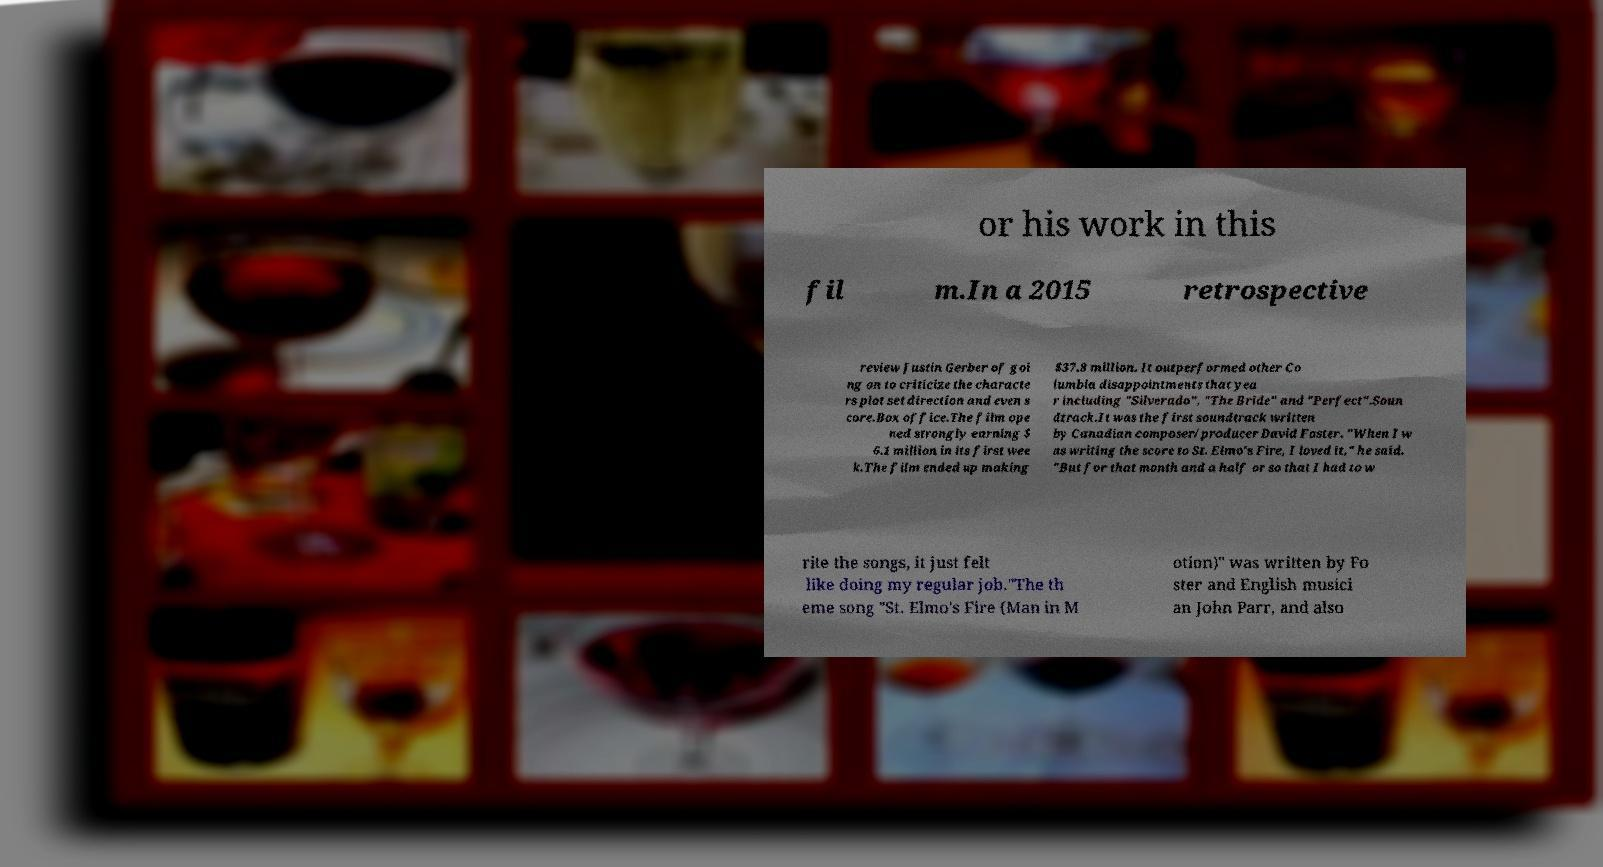Could you extract and type out the text from this image? or his work in this fil m.In a 2015 retrospective review Justin Gerber of goi ng on to criticize the characte rs plot set direction and even s core.Box office.The film ope ned strongly earning $ 6.1 million in its first wee k.The film ended up making $37.8 million. It outperformed other Co lumbia disappointments that yea r including "Silverado", "The Bride" and "Perfect".Soun dtrack.It was the first soundtrack written by Canadian composer/producer David Foster. "When I w as writing the score to St. Elmo's Fire, I loved it," he said. "But for that month and a half or so that I had to w rite the songs, it just felt like doing my regular job."The th eme song "St. Elmo's Fire (Man in M otion)" was written by Fo ster and English musici an John Parr, and also 